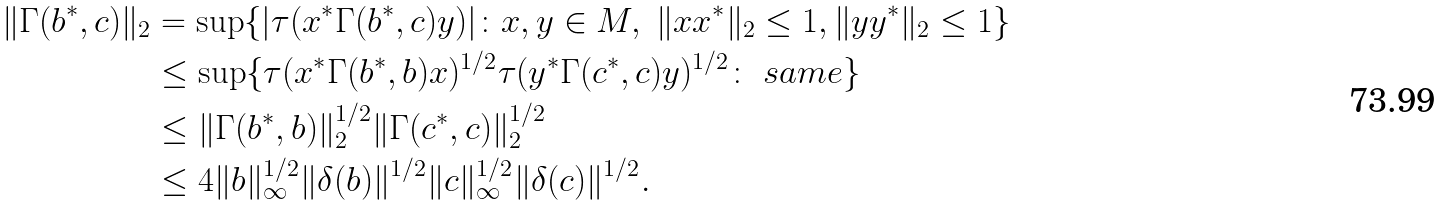Convert formula to latex. <formula><loc_0><loc_0><loc_500><loc_500>\| \Gamma ( b ^ { * } , c ) \| _ { 2 } & = \sup \{ | \tau ( x ^ { * } \Gamma ( b ^ { * } , c ) y ) | \colon x , y \in M , \ \| x x ^ { * } \| _ { 2 } \leq 1 , \| y y ^ { * } \| _ { 2 } \leq 1 \} \\ & \leq \sup \{ \tau ( x ^ { * } \Gamma ( b ^ { * } , b ) x ) ^ { 1 / 2 } \tau ( y ^ { * } \Gamma ( c ^ { * } , c ) y ) ^ { 1 / 2 } \colon \ s a m e \} \\ & \leq \| \Gamma ( b ^ { * } , b ) \| _ { 2 } ^ { 1 / 2 } \| \Gamma ( c ^ { * } , c ) \| _ { 2 } ^ { 1 / 2 } \\ & \leq 4 \| b \| _ { \infty } ^ { 1 / 2 } \| \delta ( b ) \| ^ { 1 / 2 } \| c \| _ { \infty } ^ { 1 / 2 } \| \delta ( c ) \| ^ { 1 / 2 } .</formula> 